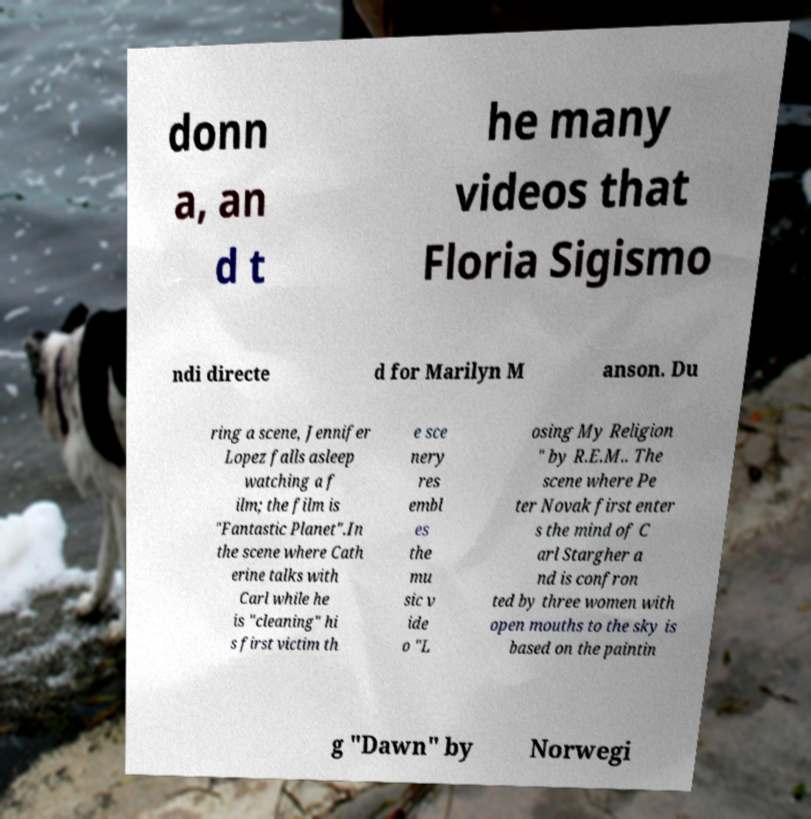Can you read and provide the text displayed in the image?This photo seems to have some interesting text. Can you extract and type it out for me? donn a, an d t he many videos that Floria Sigismo ndi directe d for Marilyn M anson. Du ring a scene, Jennifer Lopez falls asleep watching a f ilm; the film is "Fantastic Planet".In the scene where Cath erine talks with Carl while he is "cleaning" hi s first victim th e sce nery res embl es the mu sic v ide o "L osing My Religion " by R.E.M.. The scene where Pe ter Novak first enter s the mind of C arl Stargher a nd is confron ted by three women with open mouths to the sky is based on the paintin g "Dawn" by Norwegi 